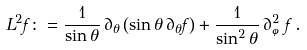Convert formula to latex. <formula><loc_0><loc_0><loc_500><loc_500>L ^ { 2 } f \colon = \frac { 1 } { \sin \theta } \, \partial _ { \theta } \left ( \sin \theta \, \partial _ { \theta } f \right ) + \frac { 1 } { \sin ^ { 2 } \theta } \, \partial _ { \varphi } ^ { 2 } f \, .</formula> 